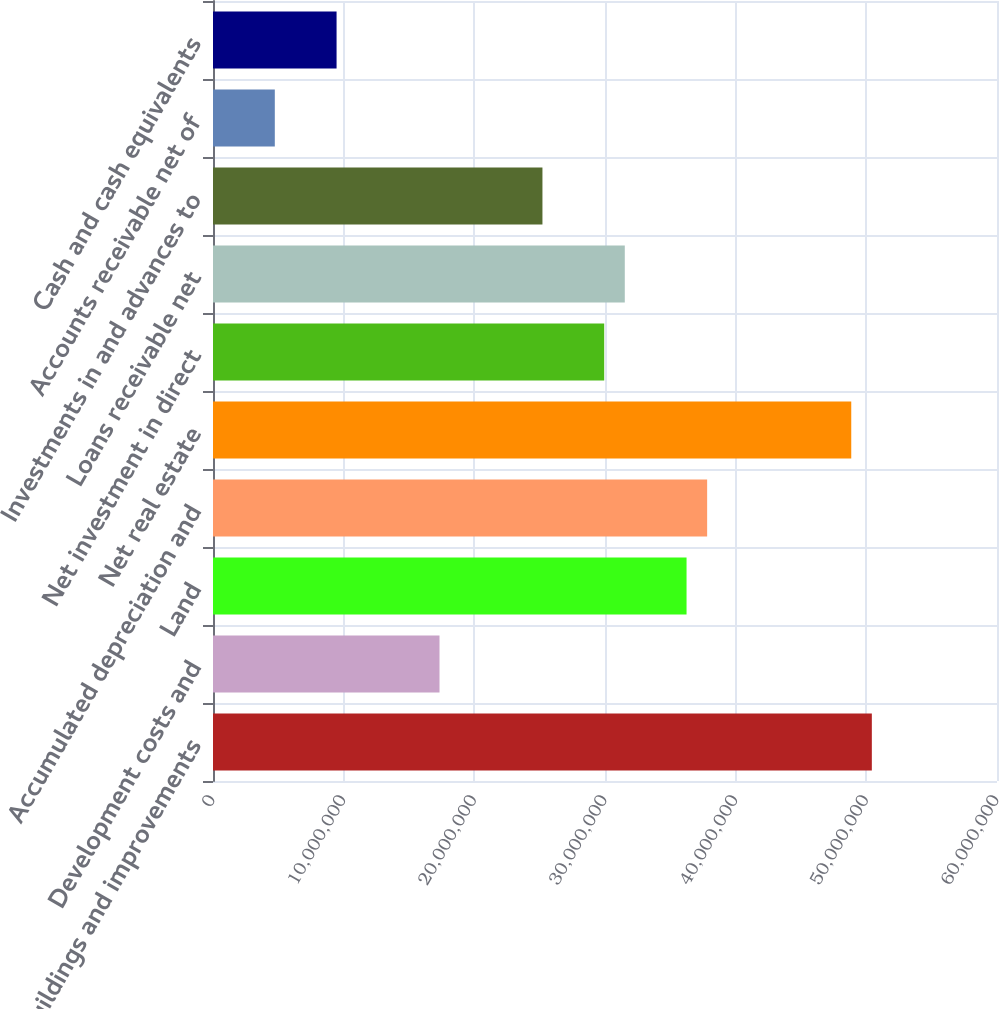<chart> <loc_0><loc_0><loc_500><loc_500><bar_chart><fcel>Buildings and improvements<fcel>Development costs and<fcel>Land<fcel>Accumulated depreciation and<fcel>Net real estate<fcel>Net investment in direct<fcel>Loans receivable net<fcel>Investments in and advances to<fcel>Accounts receivable net of<fcel>Cash and cash equivalents<nl><fcel>5.04213e+07<fcel>1.73348e+07<fcel>3.62414e+07<fcel>3.78169e+07<fcel>4.88458e+07<fcel>2.99392e+07<fcel>3.15148e+07<fcel>2.52126e+07<fcel>4.73042e+06<fcel>9.45707e+06<nl></chart> 